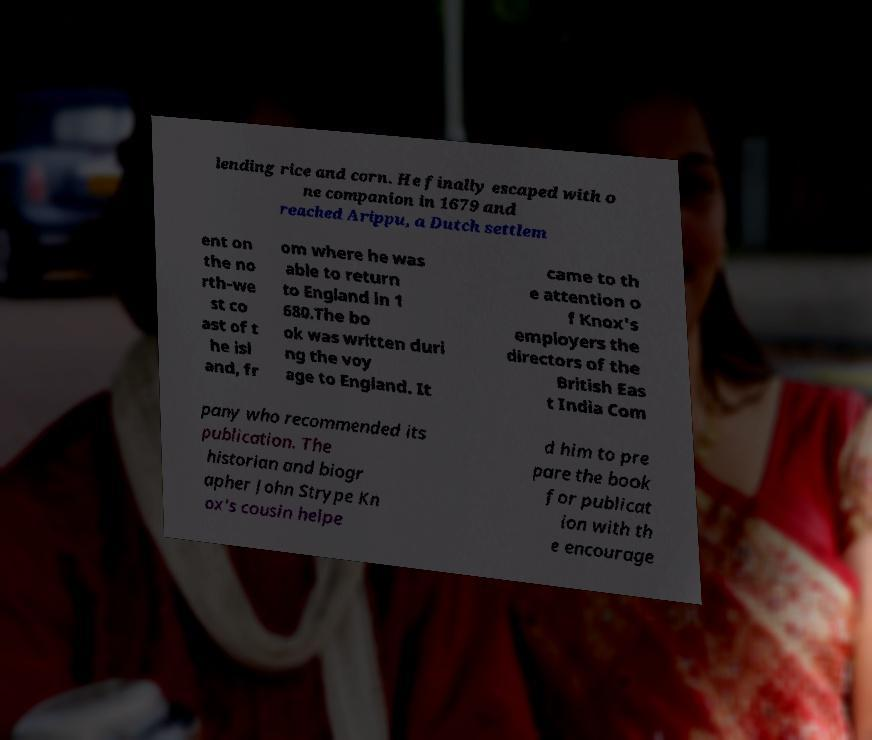Can you accurately transcribe the text from the provided image for me? lending rice and corn. He finally escaped with o ne companion in 1679 and reached Arippu, a Dutch settlem ent on the no rth-we st co ast of t he isl and, fr om where he was able to return to England in 1 680.The bo ok was written duri ng the voy age to England. It came to th e attention o f Knox's employers the directors of the British Eas t India Com pany who recommended its publication. The historian and biogr apher John Strype Kn ox's cousin helpe d him to pre pare the book for publicat ion with th e encourage 